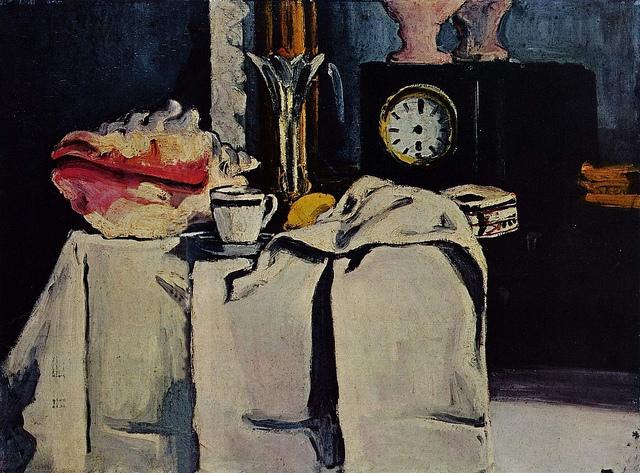Is there a website on the picture?
Keep it brief. No. What is this a painting of?
Keep it brief. Table. What style of painting is this?
Write a very short answer. Abstract. Is this real life?
Keep it brief. No. Is there a clock in the picture?
Write a very short answer. Yes. 